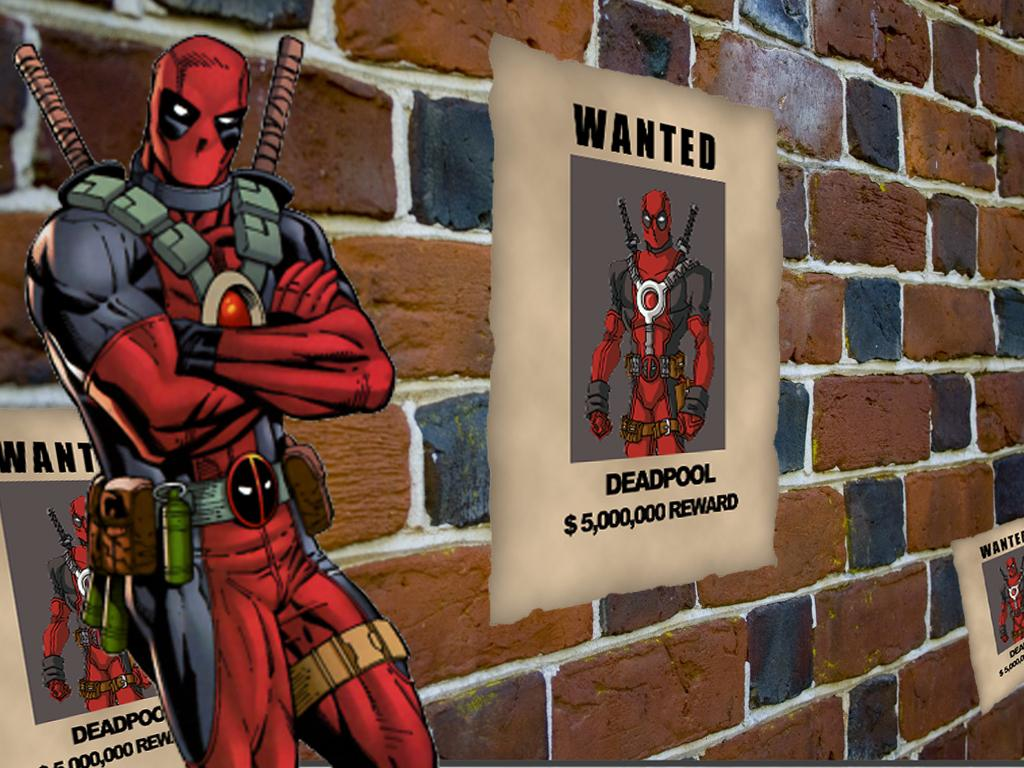<image>
Give a short and clear explanation of the subsequent image. A sign on a brick wall says Deadpool and wanted. 